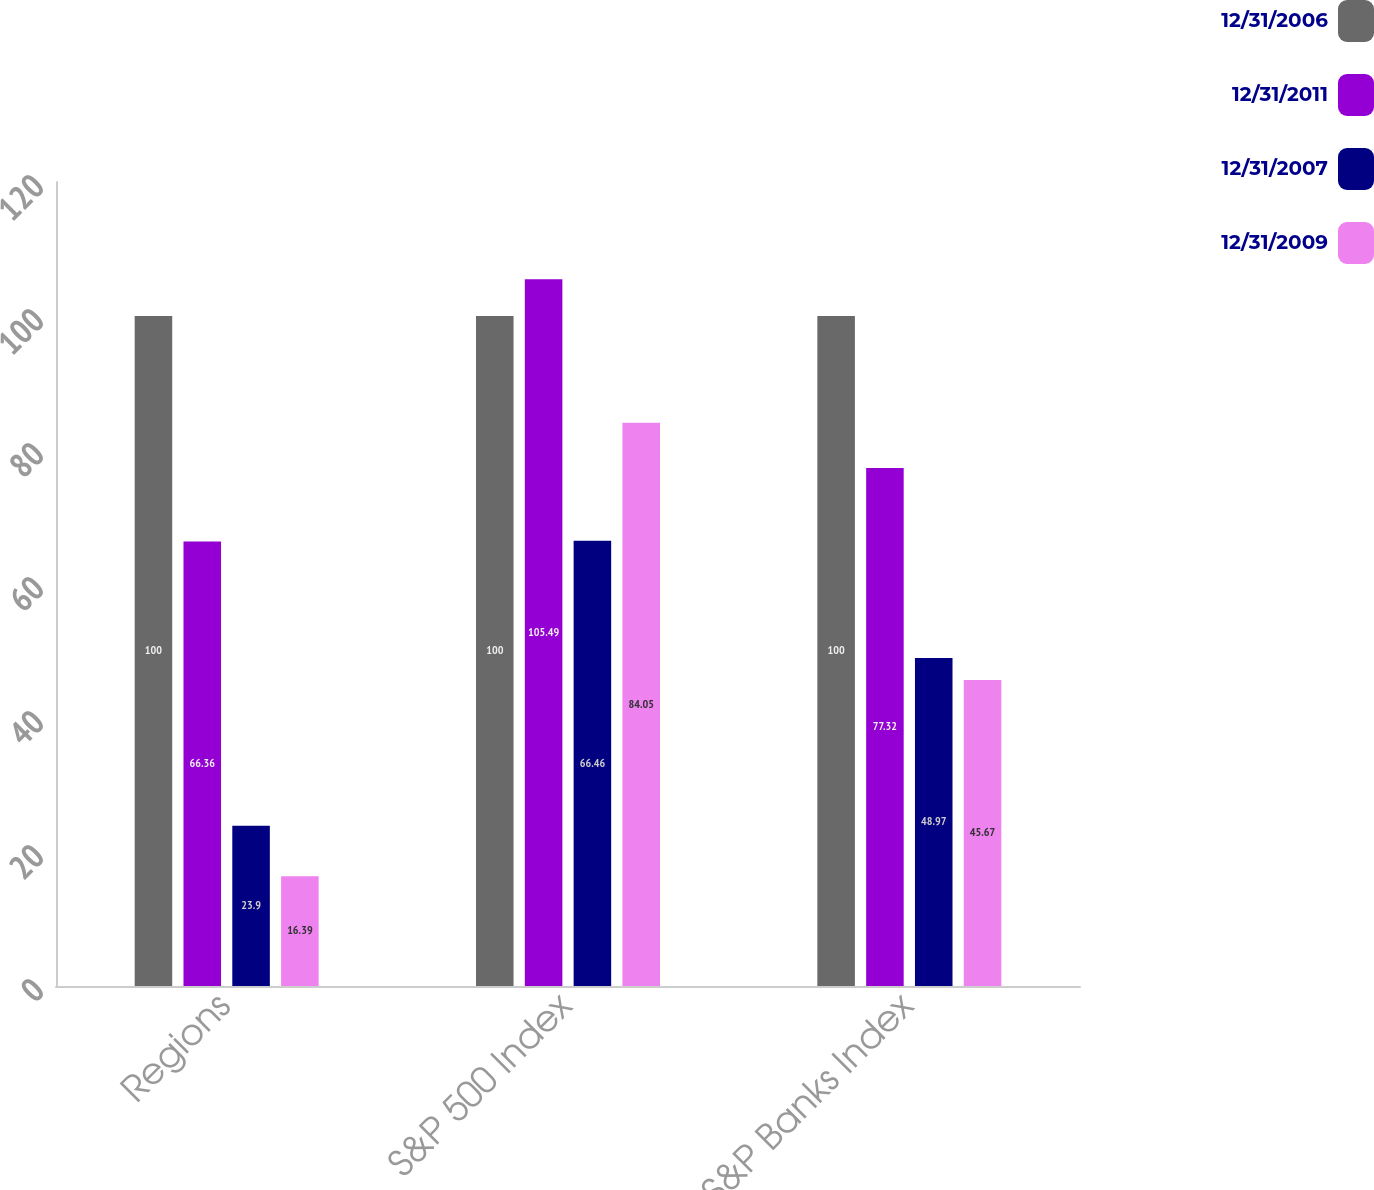Convert chart. <chart><loc_0><loc_0><loc_500><loc_500><stacked_bar_chart><ecel><fcel>Regions<fcel>S&P 500 Index<fcel>S&P Banks Index<nl><fcel>12/31/2006<fcel>100<fcel>100<fcel>100<nl><fcel>12/31/2011<fcel>66.36<fcel>105.49<fcel>77.32<nl><fcel>12/31/2007<fcel>23.9<fcel>66.46<fcel>48.97<nl><fcel>12/31/2009<fcel>16.39<fcel>84.05<fcel>45.67<nl></chart> 